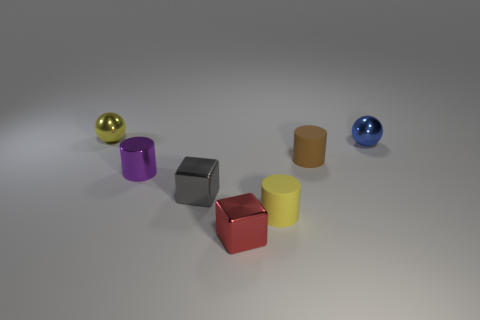What is the material of the brown cylinder in front of the tiny shiny sphere in front of the yellow metallic ball?
Give a very brief answer. Rubber. There is a blue object that is the same size as the purple shiny thing; what is its material?
Offer a terse response. Metal. There is a sphere that is on the left side of the purple shiny thing; is its size the same as the yellow cylinder?
Give a very brief answer. Yes. Do the small yellow thing that is in front of the small blue shiny sphere and the purple thing have the same shape?
Give a very brief answer. Yes. What number of things are either small gray metal spheres or small objects that are to the right of the tiny brown matte object?
Offer a very short reply. 1. Are there fewer big gray rubber things than tiny red cubes?
Keep it short and to the point. Yes. Is the number of tiny purple matte cubes greater than the number of shiny cylinders?
Offer a terse response. No. How many other things are the same material as the tiny gray block?
Your answer should be compact. 4. There is a small metal sphere in front of the small metal object that is behind the small blue thing; what number of blue metallic spheres are to the left of it?
Provide a short and direct response. 0. How many rubber objects are tiny brown objects or gray blocks?
Provide a short and direct response. 1. 